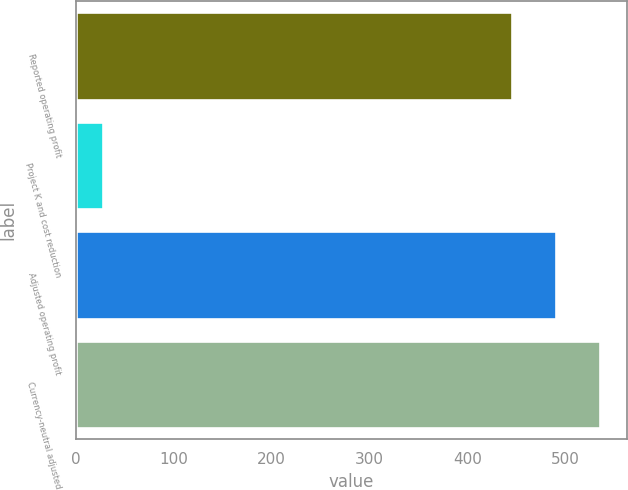Convert chart. <chart><loc_0><loc_0><loc_500><loc_500><bar_chart><fcel>Reported operating profit<fcel>Project K and cost reduction<fcel>Adjusted operating profit<fcel>Currency-neutral adjusted<nl><fcel>446<fcel>28<fcel>490.9<fcel>535.8<nl></chart> 